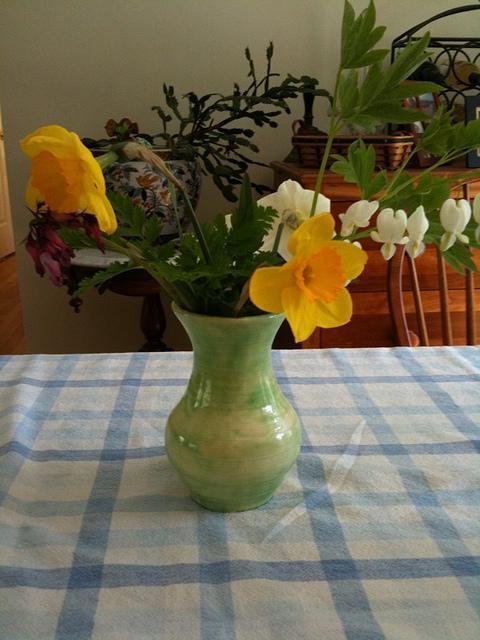How many chairs are in the photo?
Give a very brief answer. 1. 